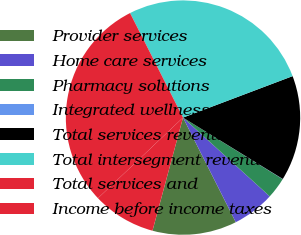<chart> <loc_0><loc_0><loc_500><loc_500><pie_chart><fcel>Provider services<fcel>Home care services<fcel>Pharmacy solutions<fcel>Integrated wellness services<fcel>Total services revenues<fcel>Total intersegment revenues<fcel>Total services and<fcel>Income before income taxes<nl><fcel>11.63%<fcel>5.83%<fcel>2.93%<fcel>0.03%<fcel>14.53%<fcel>26.71%<fcel>29.61%<fcel>8.73%<nl></chart> 